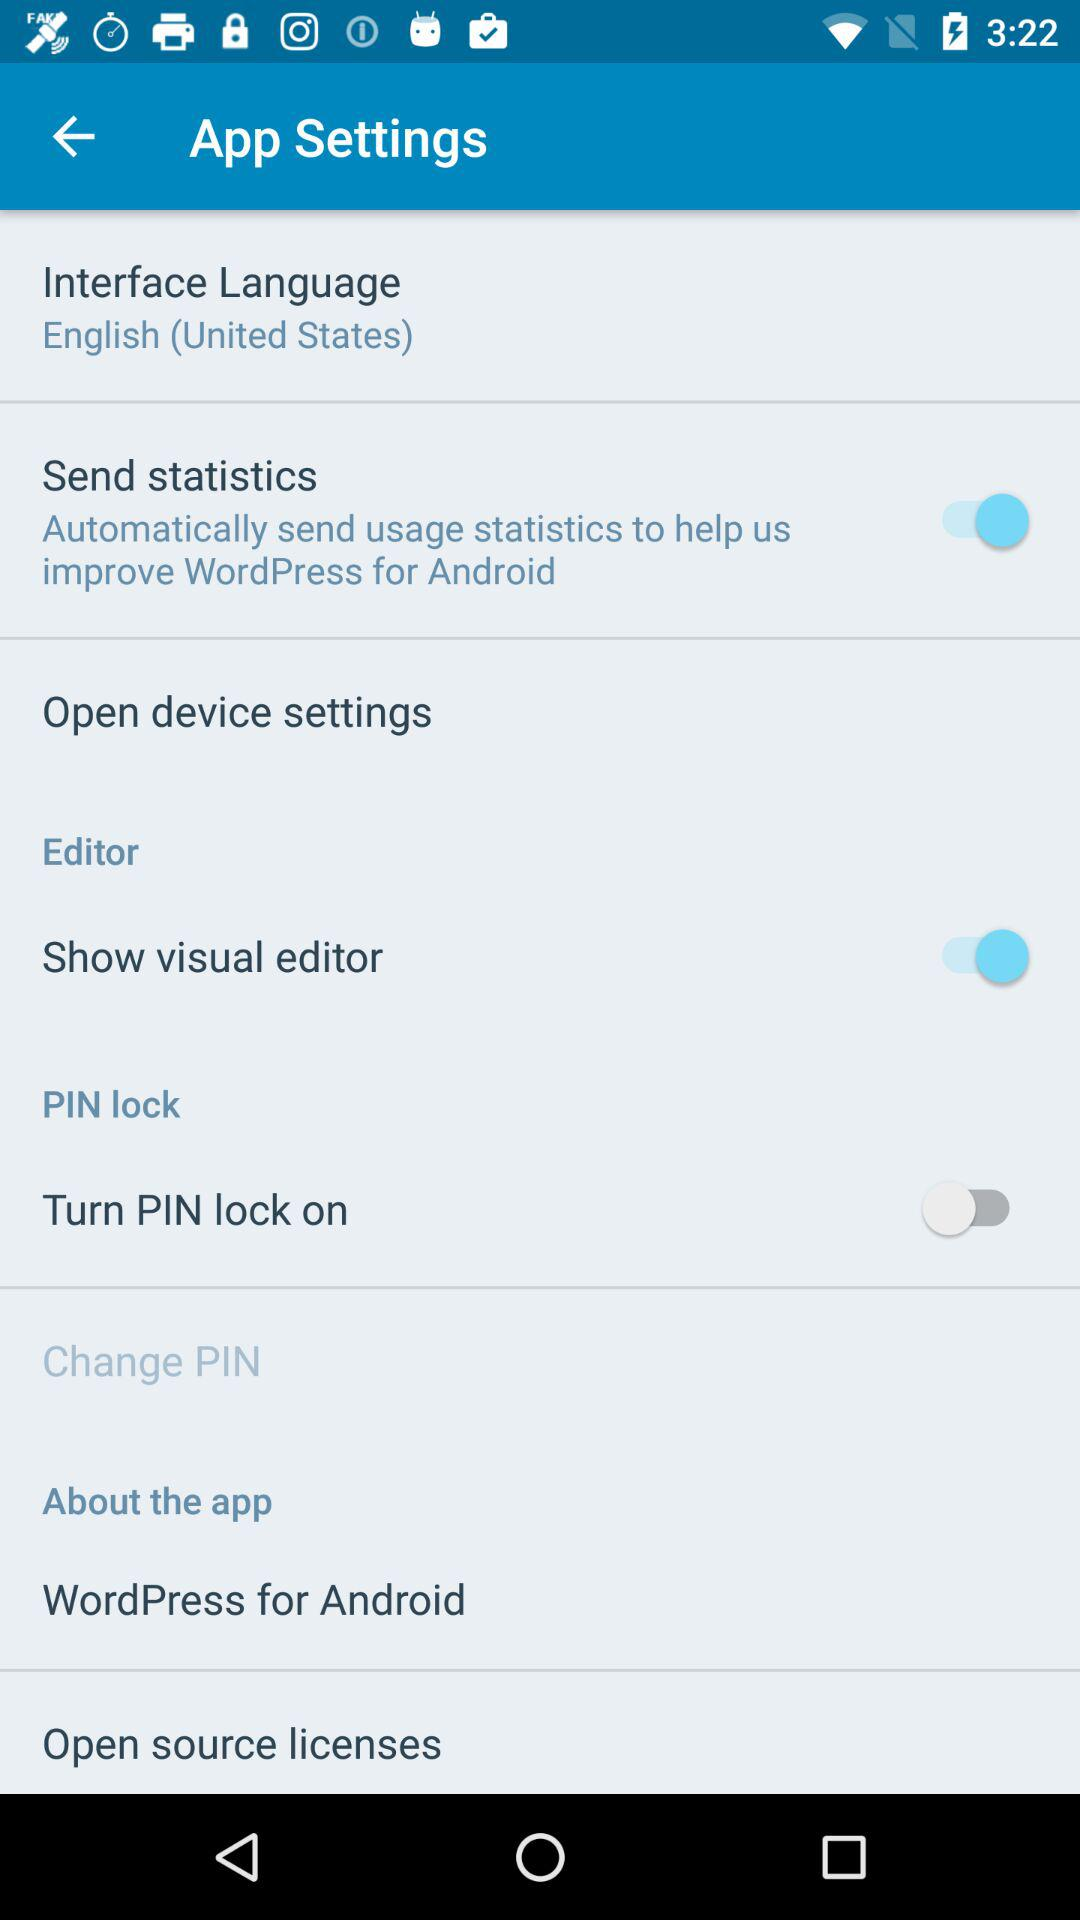What is the selected language? The selected language is English (United States). 